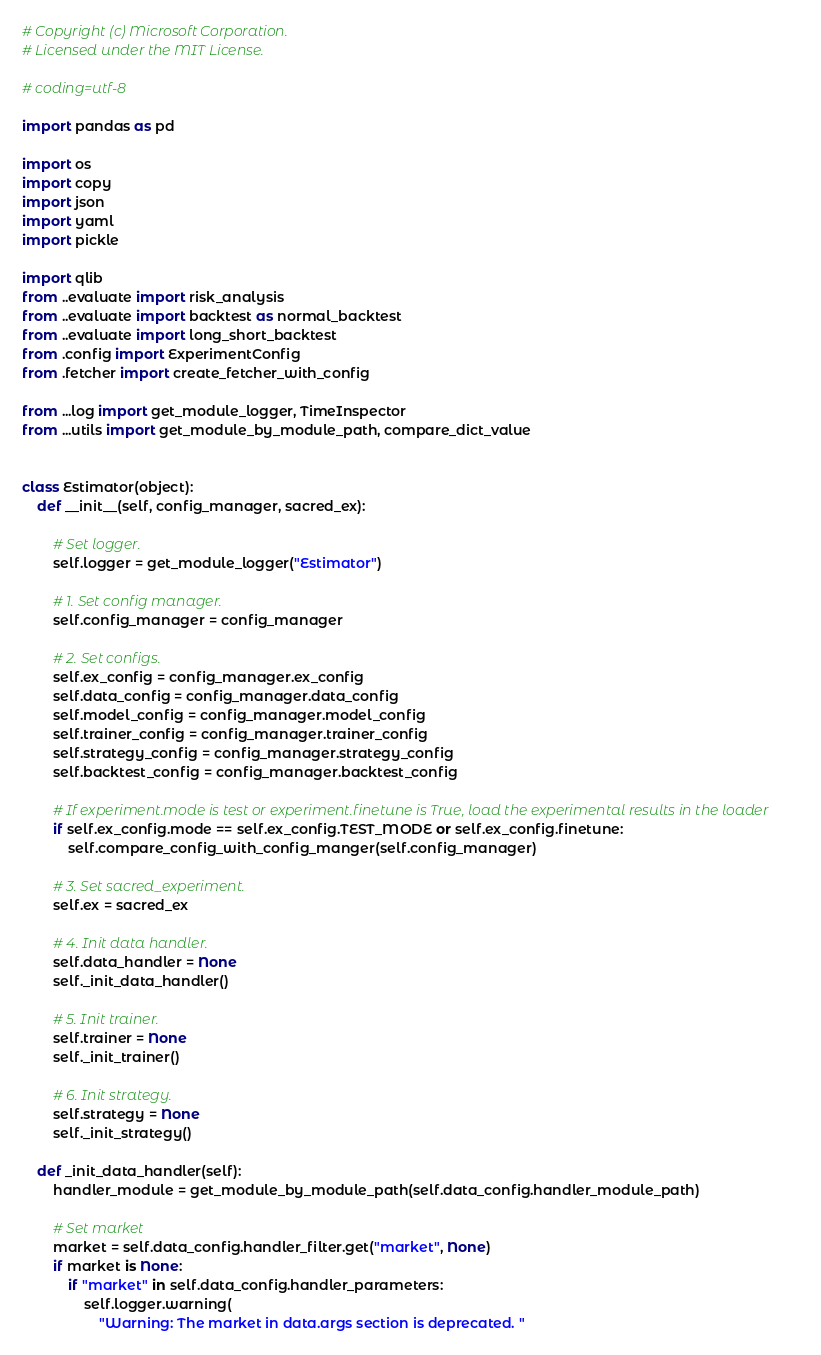Convert code to text. <code><loc_0><loc_0><loc_500><loc_500><_Python_># Copyright (c) Microsoft Corporation.
# Licensed under the MIT License.

# coding=utf-8

import pandas as pd

import os
import copy
import json
import yaml
import pickle

import qlib
from ..evaluate import risk_analysis
from ..evaluate import backtest as normal_backtest
from ..evaluate import long_short_backtest
from .config import ExperimentConfig
from .fetcher import create_fetcher_with_config

from ...log import get_module_logger, TimeInspector
from ...utils import get_module_by_module_path, compare_dict_value


class Estimator(object):
    def __init__(self, config_manager, sacred_ex):

        # Set logger.
        self.logger = get_module_logger("Estimator")

        # 1. Set config manager.
        self.config_manager = config_manager

        # 2. Set configs.
        self.ex_config = config_manager.ex_config
        self.data_config = config_manager.data_config
        self.model_config = config_manager.model_config
        self.trainer_config = config_manager.trainer_config
        self.strategy_config = config_manager.strategy_config
        self.backtest_config = config_manager.backtest_config

        # If experiment.mode is test or experiment.finetune is True, load the experimental results in the loader
        if self.ex_config.mode == self.ex_config.TEST_MODE or self.ex_config.finetune:
            self.compare_config_with_config_manger(self.config_manager)

        # 3. Set sacred_experiment.
        self.ex = sacred_ex

        # 4. Init data handler.
        self.data_handler = None
        self._init_data_handler()

        # 5. Init trainer.
        self.trainer = None
        self._init_trainer()

        # 6. Init strategy.
        self.strategy = None
        self._init_strategy()

    def _init_data_handler(self):
        handler_module = get_module_by_module_path(self.data_config.handler_module_path)

        # Set market
        market = self.data_config.handler_filter.get("market", None)
        if market is None:
            if "market" in self.data_config.handler_parameters:
                self.logger.warning(
                    "Warning: The market in data.args section is deprecated. "</code> 